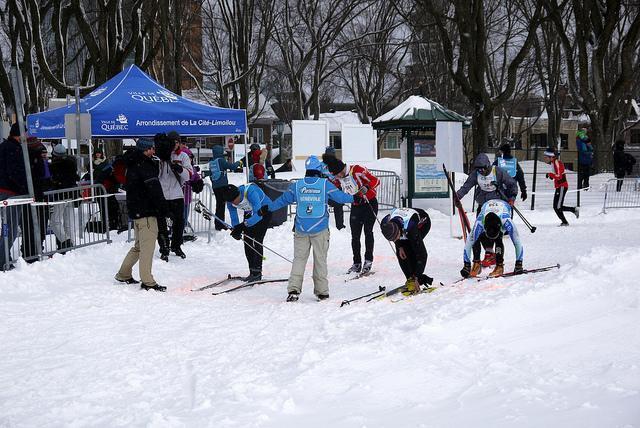How many people are visible?
Give a very brief answer. 8. 